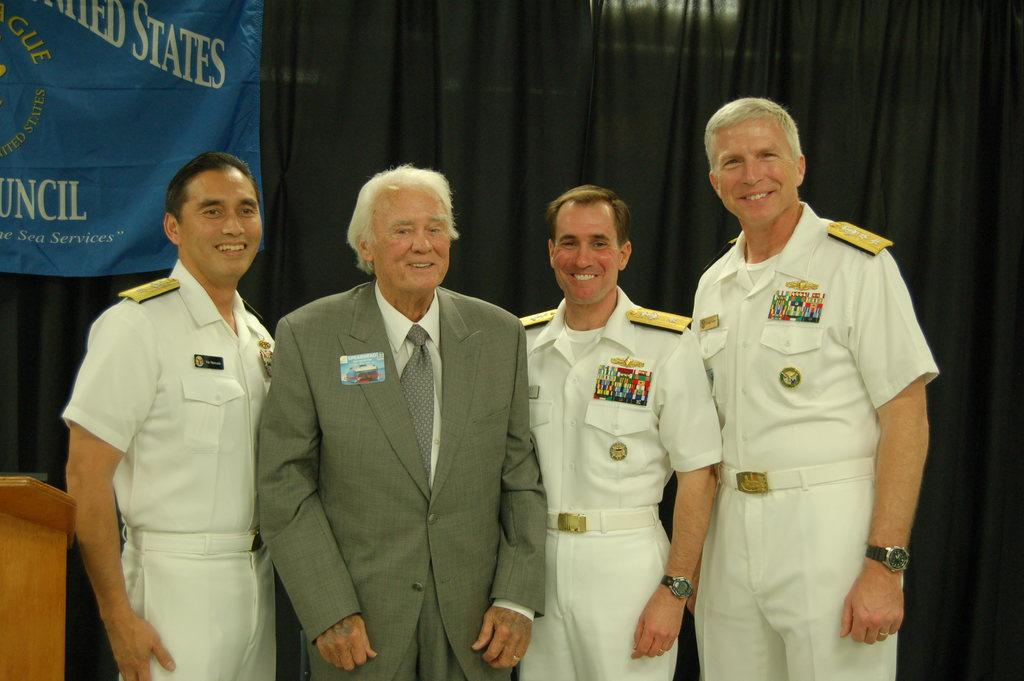<image>
Describe the image concisely. military men stand in front of a sign with STATES on it 